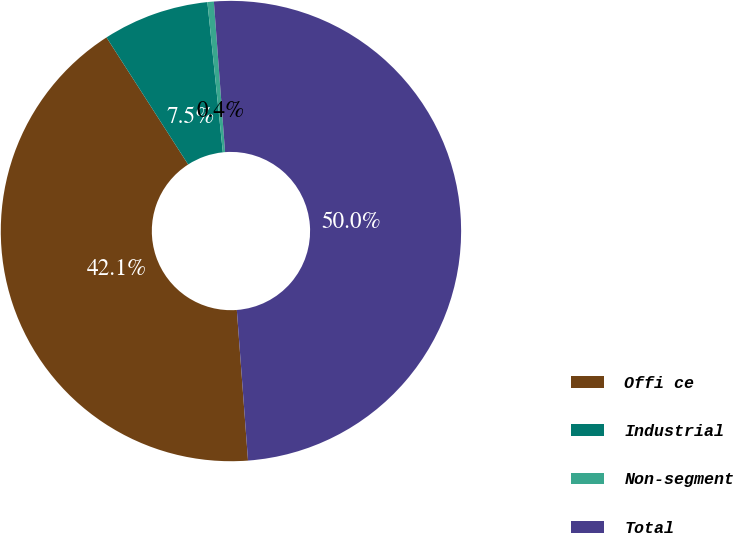Convert chart. <chart><loc_0><loc_0><loc_500><loc_500><pie_chart><fcel>Offi ce<fcel>Industrial<fcel>Non-segment<fcel>Total<nl><fcel>42.09%<fcel>7.46%<fcel>0.45%<fcel>50.0%<nl></chart> 